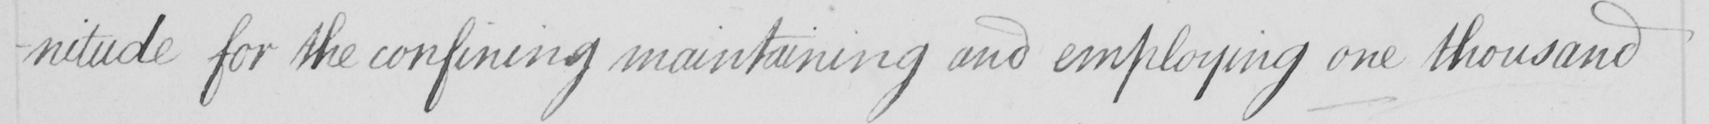Transcribe the text shown in this historical manuscript line. -nitude for the confining maintaining and employing one thousand 